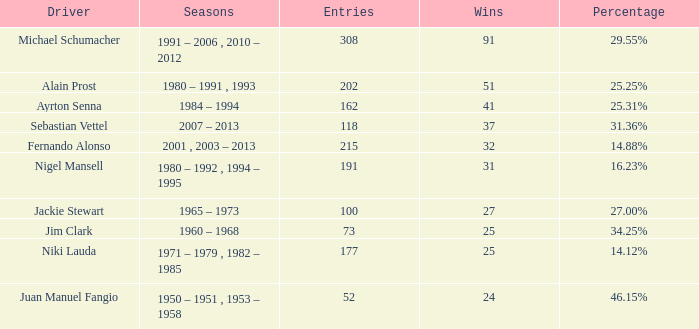Which driver has less than 37 wins and at 14.12%? 177.0. 